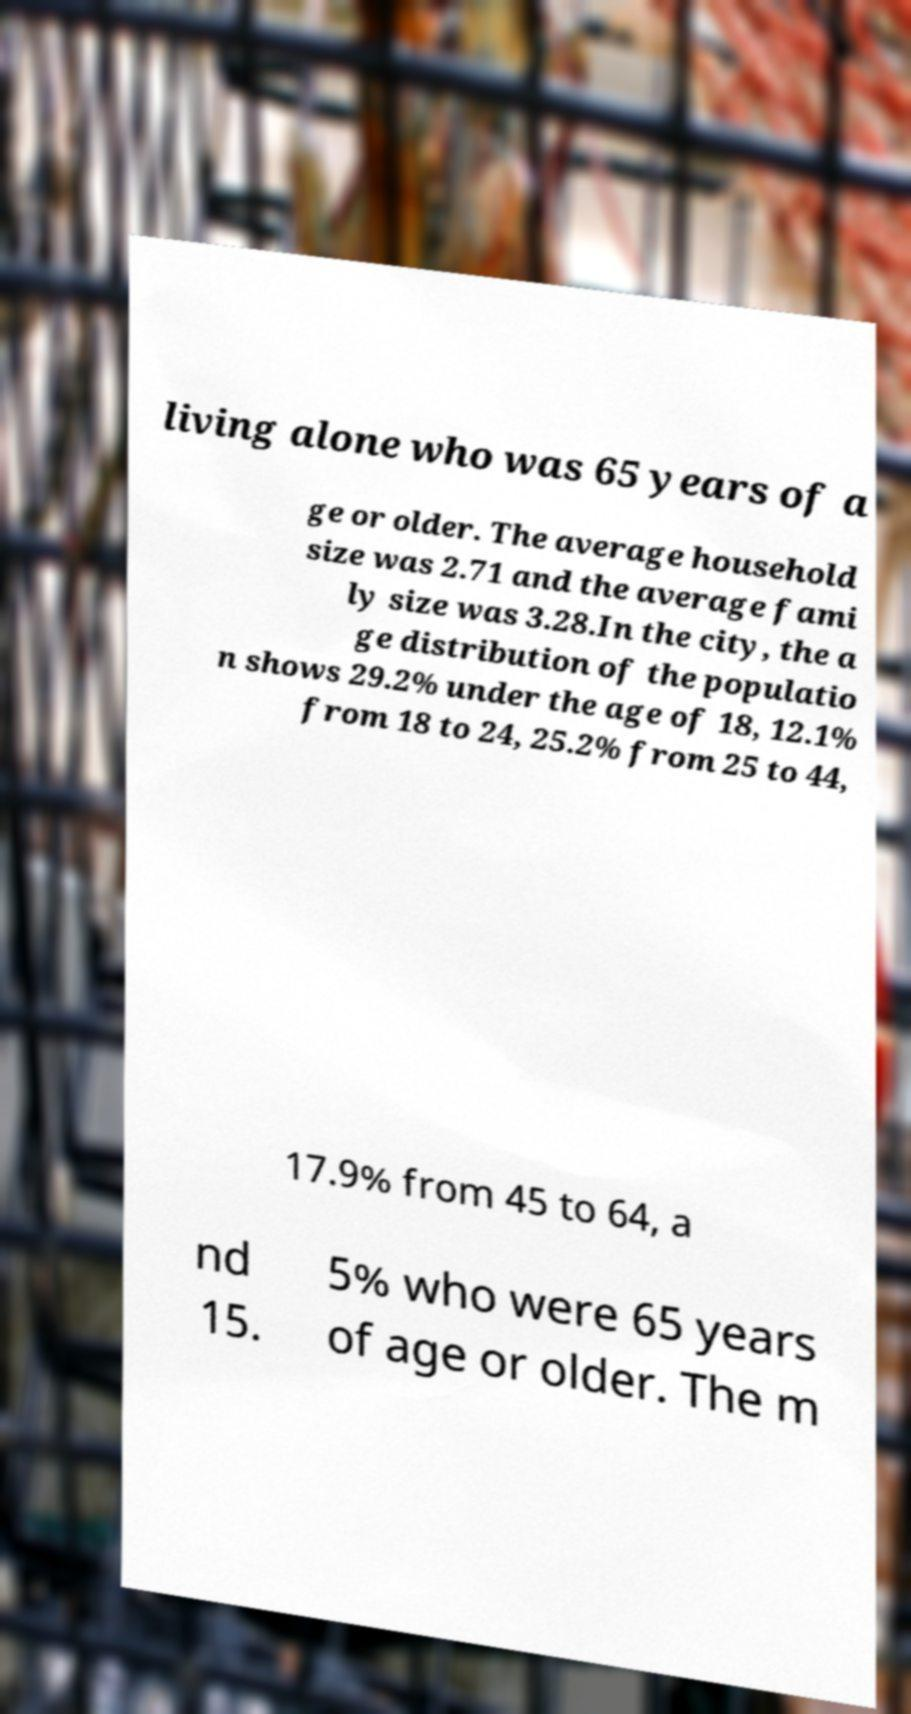Could you extract and type out the text from this image? living alone who was 65 years of a ge or older. The average household size was 2.71 and the average fami ly size was 3.28.In the city, the a ge distribution of the populatio n shows 29.2% under the age of 18, 12.1% from 18 to 24, 25.2% from 25 to 44, 17.9% from 45 to 64, a nd 15. 5% who were 65 years of age or older. The m 